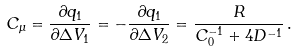Convert formula to latex. <formula><loc_0><loc_0><loc_500><loc_500>C _ { \mu } = \frac { \partial q _ { 1 } } { \partial \Delta V _ { 1 } } = - \frac { \partial q _ { 1 } } { \partial \Delta V _ { 2 } } = \frac { R } { C _ { 0 } ^ { - 1 } + 4 D ^ { - 1 } } \, .</formula> 